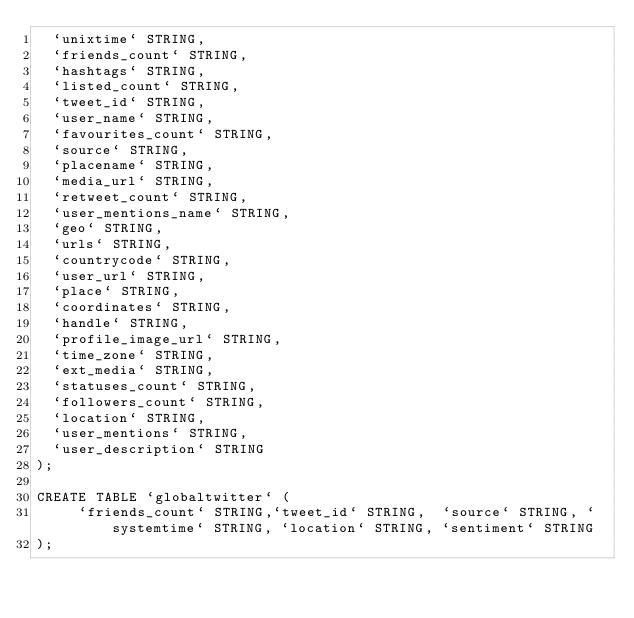<code> <loc_0><loc_0><loc_500><loc_500><_SQL_>  `unixtime` STRING,
  `friends_count` STRING,
  `hashtags` STRING,
  `listed_count` STRING,
  `tweet_id` STRING,
  `user_name` STRING,
  `favourites_count` STRING,
  `source` STRING,
  `placename` STRING,
  `media_url` STRING,
  `retweet_count` STRING,
  `user_mentions_name` STRING,
  `geo` STRING,
  `urls` STRING,
  `countrycode` STRING,
  `user_url` STRING,
  `place` STRING,
  `coordinates` STRING,
  `handle` STRING,
  `profile_image_url` STRING,
  `time_zone` STRING,
  `ext_media` STRING,
  `statuses_count` STRING,
  `followers_count` STRING,
  `location` STRING,
  `user_mentions` STRING,
  `user_description` STRING
);

CREATE TABLE `globaltwitter` (
     `friends_count` STRING,`tweet_id` STRING,  `source` STRING, `systemtime` STRING, `location` STRING, `sentiment` STRING
);

</code> 